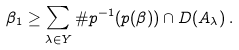<formula> <loc_0><loc_0><loc_500><loc_500>\beta _ { 1 } \geq \sum _ { \lambda \in Y } \# p ^ { - 1 } ( p ( \beta ) ) \cap D ( A _ { \lambda } ) \, .</formula> 